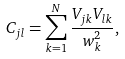Convert formula to latex. <formula><loc_0><loc_0><loc_500><loc_500>C _ { j l } = \sum _ { k = 1 } ^ { N } \frac { V _ { j k } V _ { l k } } { w _ { k } ^ { 2 } } ,</formula> 